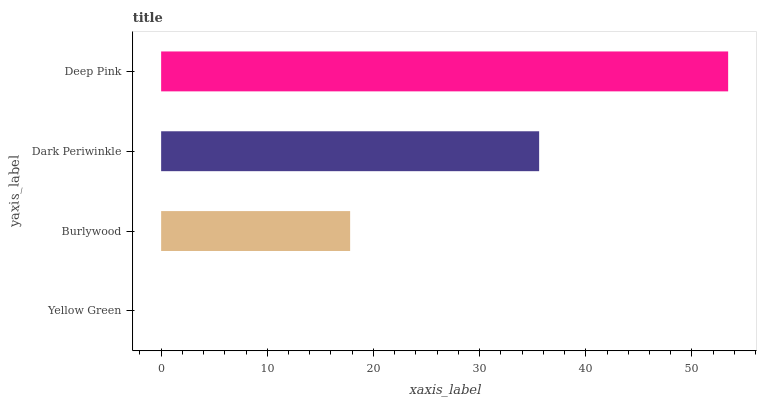Is Yellow Green the minimum?
Answer yes or no. Yes. Is Deep Pink the maximum?
Answer yes or no. Yes. Is Burlywood the minimum?
Answer yes or no. No. Is Burlywood the maximum?
Answer yes or no. No. Is Burlywood greater than Yellow Green?
Answer yes or no. Yes. Is Yellow Green less than Burlywood?
Answer yes or no. Yes. Is Yellow Green greater than Burlywood?
Answer yes or no. No. Is Burlywood less than Yellow Green?
Answer yes or no. No. Is Dark Periwinkle the high median?
Answer yes or no. Yes. Is Burlywood the low median?
Answer yes or no. Yes. Is Yellow Green the high median?
Answer yes or no. No. Is Dark Periwinkle the low median?
Answer yes or no. No. 